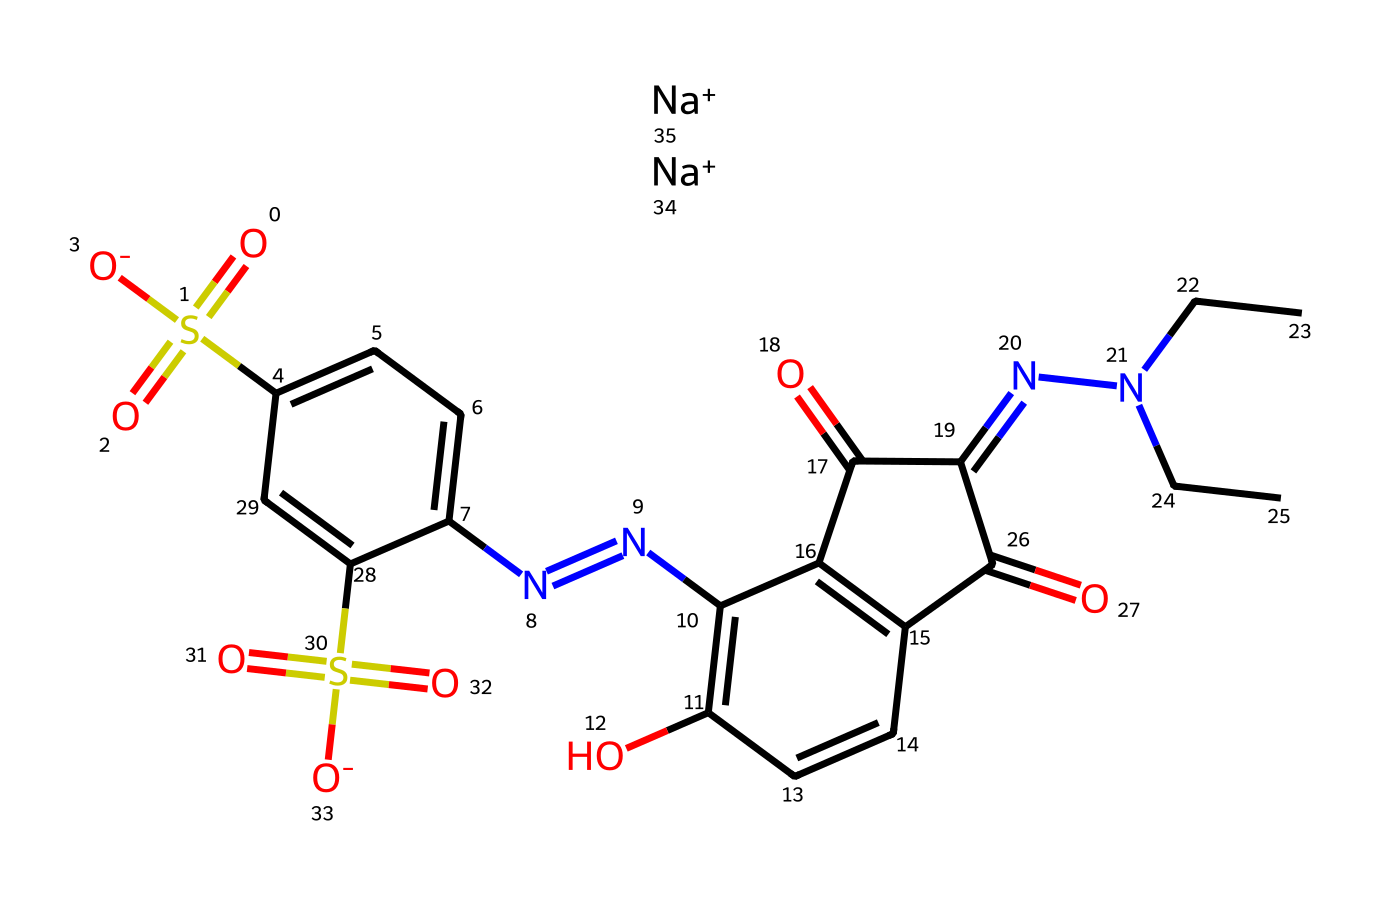What is the primary functional group present in this chemical? The chemical features a sulfonic acid group (-SO3H) and a nitrile functional group, which can be identified by the presence of sulfur and nitrogen atoms connected to oxygen. The sulfonic acid is indicated by the three oxygen atoms connected to sulfur.
Answer: sulfonic acid How many aromatic rings are present in the structure? The structure contains a total of three aromatic rings. This can be determined by identifying the alternating double bonds in the rings and the presence of the benzene-like structures.
Answer: three What type of chemical compound is represented by this SMILES? The presence of nitrogen-nitrogen double bonds and overall complex structure indicates that this compound is a dye. Dyes are often used for colorization in various applications including food and textiles.
Answer: dye What elements are present in this chemical? By analyzing the SMILES, the elements can be counted, which includes carbon (C), hydrogen (H), sulfur (S), oxygen (O), and nitrogen (N), constituting the complete elemental makeup of the molecule.
Answer: carbon, hydrogen, sulfur, oxygen, nitrogen What is the molecular mass of this chemical compound? The molecular mass can be calculated by summing the atomic masses of all the constituent atoms present in the structure, derived from the SMILES representation. This requires knowledge of atomic weights for each element found in the compound.
Answer: 432.49 g/mol 